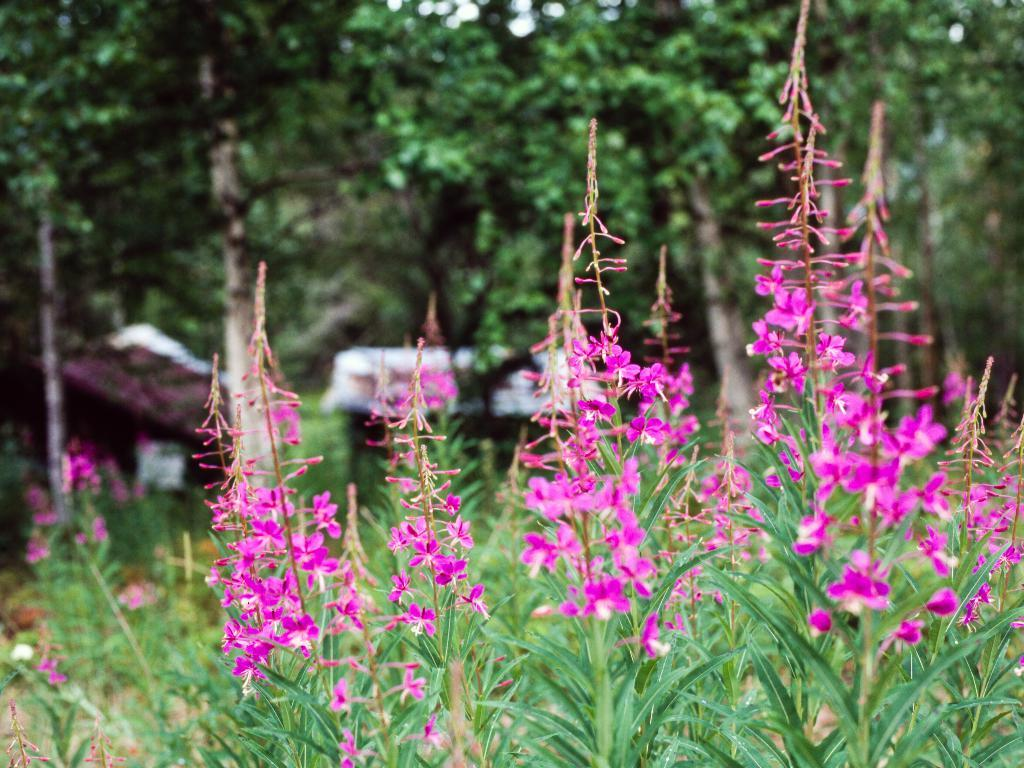What type of flowers can be seen in the foreground of the image? There are pink flowers in the foreground of the image. What are the flowers growing on? The flowers are on plants. What can be seen in the background of the image? There are houses and trees in the background of the image. What type of secretary can be seen working in the image? There is no secretary present in the image; it features pink flowers in the foreground and houses and trees in the background. 